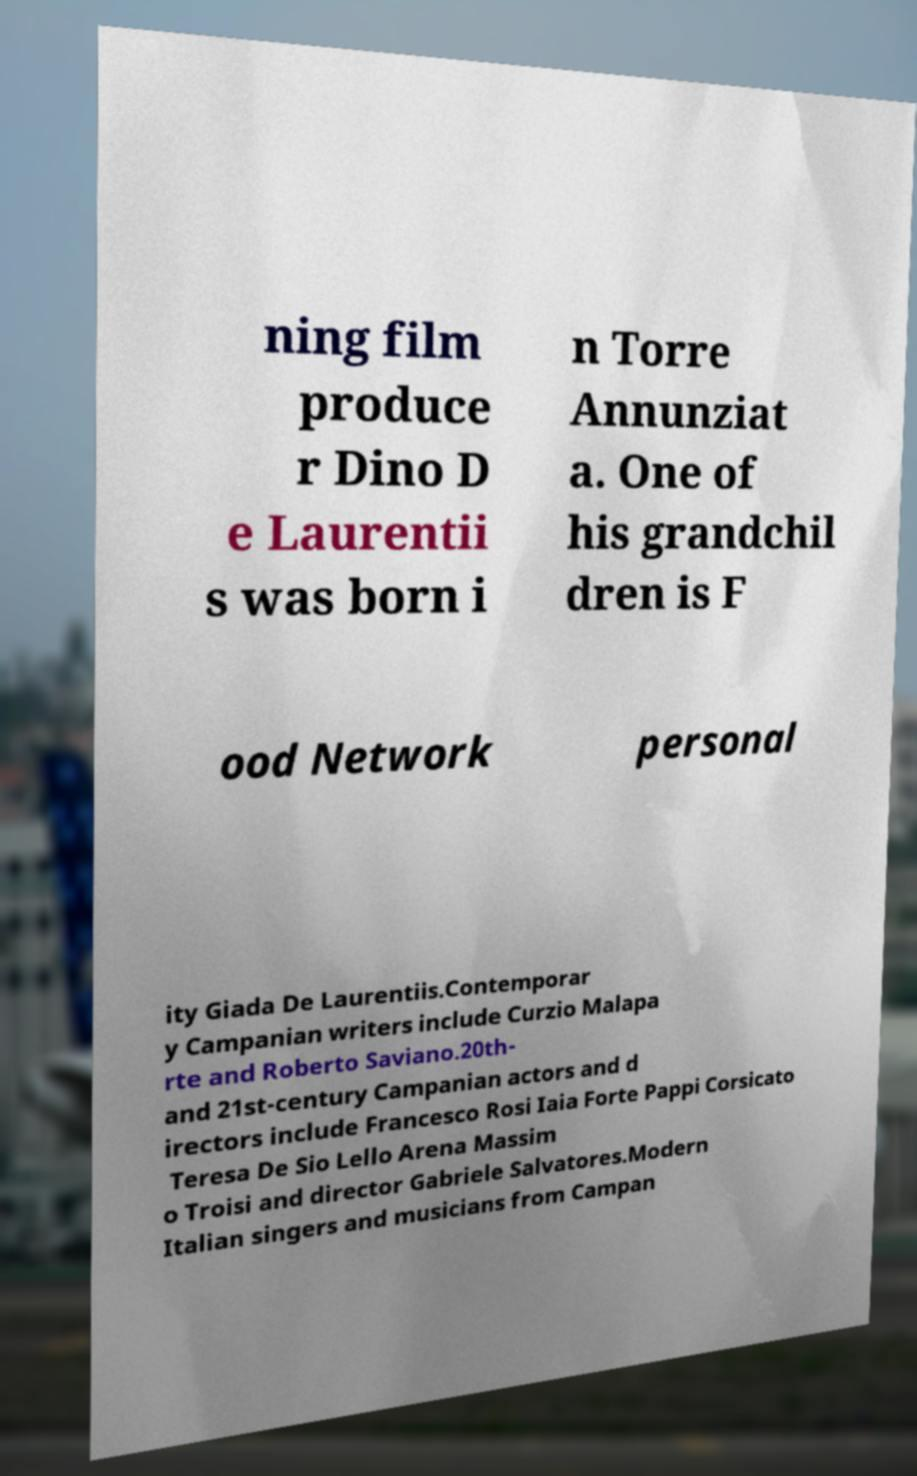Can you accurately transcribe the text from the provided image for me? ning film produce r Dino D e Laurentii s was born i n Torre Annunziat a. One of his grandchil dren is F ood Network personal ity Giada De Laurentiis.Contemporar y Campanian writers include Curzio Malapa rte and Roberto Saviano.20th- and 21st-century Campanian actors and d irectors include Francesco Rosi Iaia Forte Pappi Corsicato Teresa De Sio Lello Arena Massim o Troisi and director Gabriele Salvatores.Modern Italian singers and musicians from Campan 